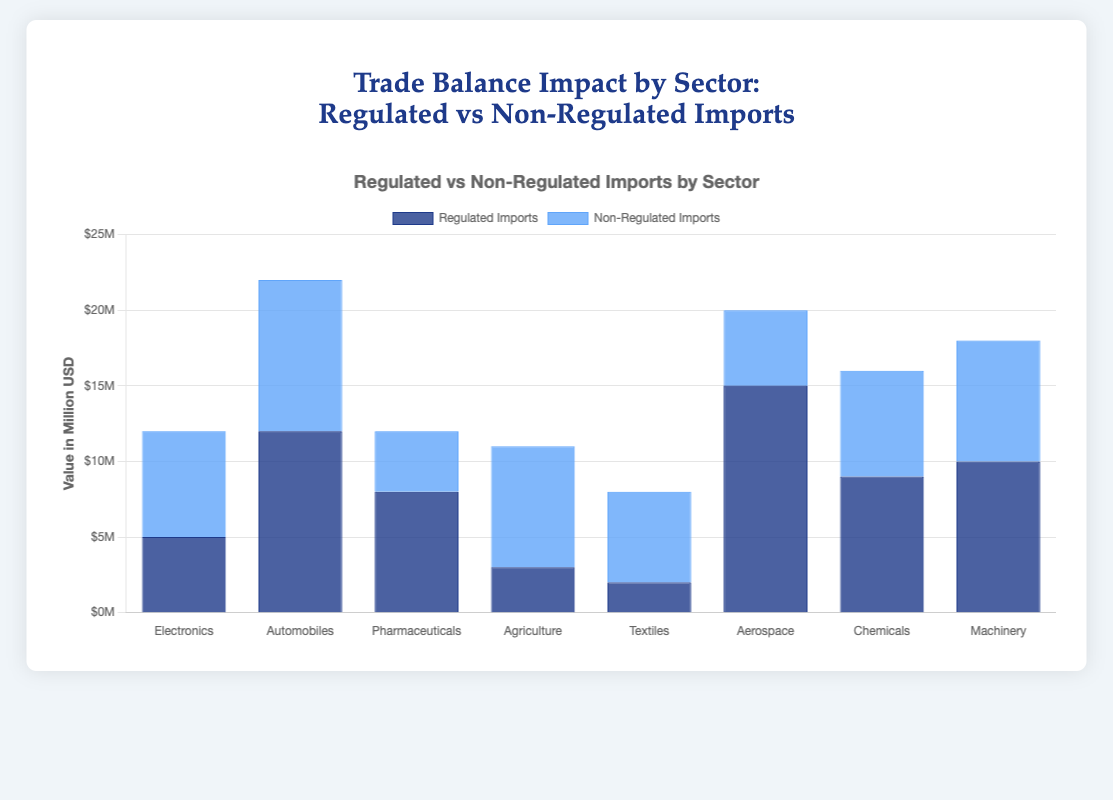Which sector has the highest value of regulated imports? The bar for regulated imports in the "Aerospace" sector is the tallest, indicating it has the highest value.
Answer: Aerospace Comparing Pharmaceuticals and Textiles, which sector has higher non-regulated imports, and by how much? Pharmaceuticals have non-regulated imports of 4 million, while Textiles have non-regulated imports of 6 million. The difference is 6 million - 4 million = 2 million.
Answer: Textiles, 2 million What is the total value of regulated imports for the Machinery and Automobiles sectors combined? Machinery's regulated imports are 10 million, and Automobiles' regulated imports are 12 million. Combined, this sums up to 10 million + 12 million = 22 million.
Answer: 22 million Which sector shows the largest difference between regulated and non-regulated imports? The Agriculture sector has regulated imports of 3 million and non-regulated imports of 8 million, making the difference 8 million - 3 million = 5 million, which is the largest among all sectors.
Answer: Agriculture What is the visual color difference used to represent regulated and non-regulated imports on the chart? The bars representing regulated imports are in a darker blue, while the bars for non-regulated imports are in a lighter blue shade.
Answer: Darker blue for regulated, lighter blue for non-regulated Is the value of Electronics’ non-regulated imports greater than the Aerospace’s non-regulated imports? Electronics have non-regulated imports of 7 million, while Aerospace has non-regulated imports of 5 million. Since 7 million is greater than 5 million, Electronics’ non-regulated imports are greater.
Answer: Yes By how much do Automobiles' exports exceed their total imports (regulated and non-regulated combined)? Automobiles' total imports are 12 million (regulated) + 10 million (non-regulated) = 22 million. Their export value is 20 million. The exports exceed total imports by 20 million - 22 million = -2 million, actually not exceeding but rather falling short by 2 million.
Answer: They don't exceed, fall short by 2 million What is the difference in regulated imports between the Chemicals and Pharmaceuticals sectors? Regulated imports for Chemicals are 9 million, and for Pharmaceuticals, they are 8 million. The difference is 9 million - 8 million = 1 million.
Answer: 1 million Which sector has the closest value of regulated and non-regulated imports, and what is the difference? The Pharmaceuticals sector has regulated imports of 8 million and non-regulated imports of 4 million, with a difference of 4 million. This is the smallest difference compared to other sectors.
Answer: Pharmaceuticals, 4 million In which sectors do non-regulated imports exceed regulated imports? List all such sectors. Non-regulated imports exceed regulated imports in Electronics (7 million > 5 million), Agriculture (8 million > 3 million), and Textiles (6 million > 2 million).
Answer: Electronics, Agriculture, Textiles 